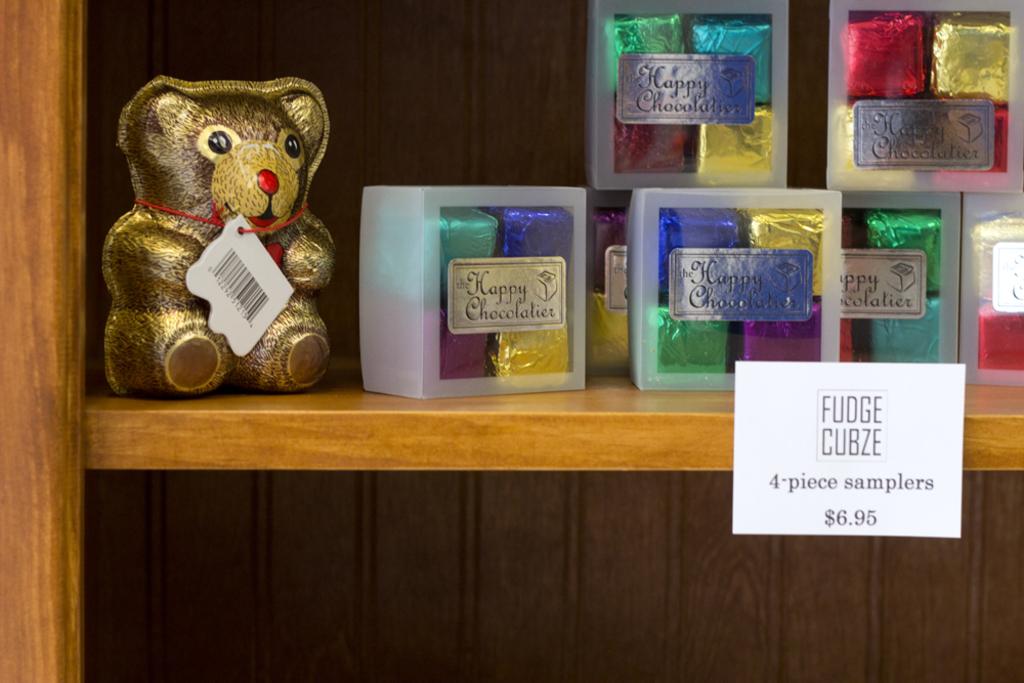How many samples come in the fudge cubze?
Your response must be concise. 4. How much is the fudge?
Offer a terse response. $6.95. 